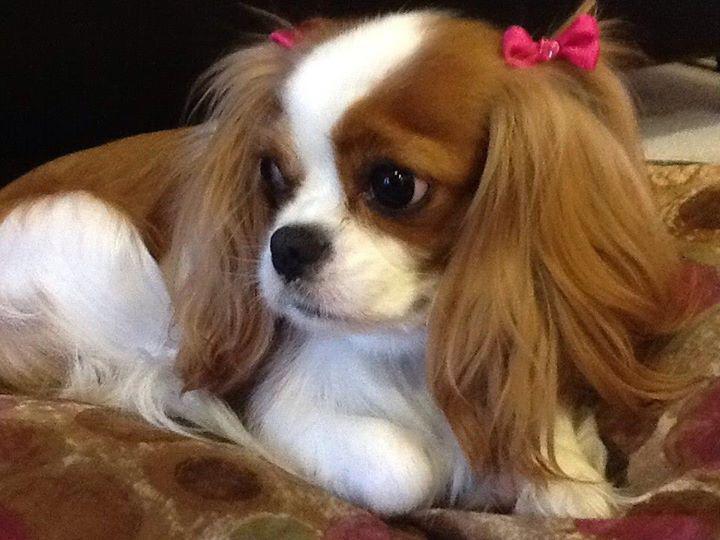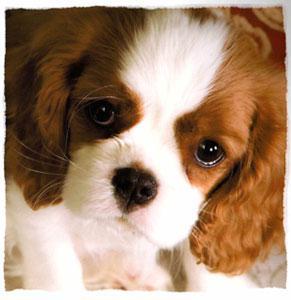The first image is the image on the left, the second image is the image on the right. Considering the images on both sides, is "the animal in the image on the left is lying down" valid? Answer yes or no. Yes. The first image is the image on the left, the second image is the image on the right. Examine the images to the left and right. Is the description "There are only two puppies and neither has bows in its hair." accurate? Answer yes or no. No. 